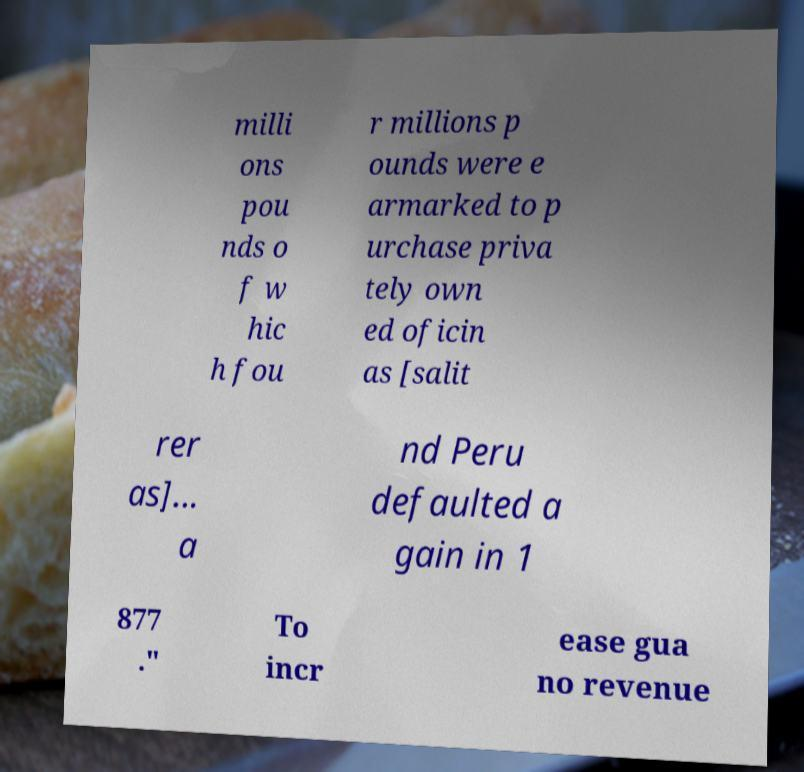Can you accurately transcribe the text from the provided image for me? milli ons pou nds o f w hic h fou r millions p ounds were e armarked to p urchase priva tely own ed oficin as [salit rer as]... a nd Peru defaulted a gain in 1 877 ." To incr ease gua no revenue 